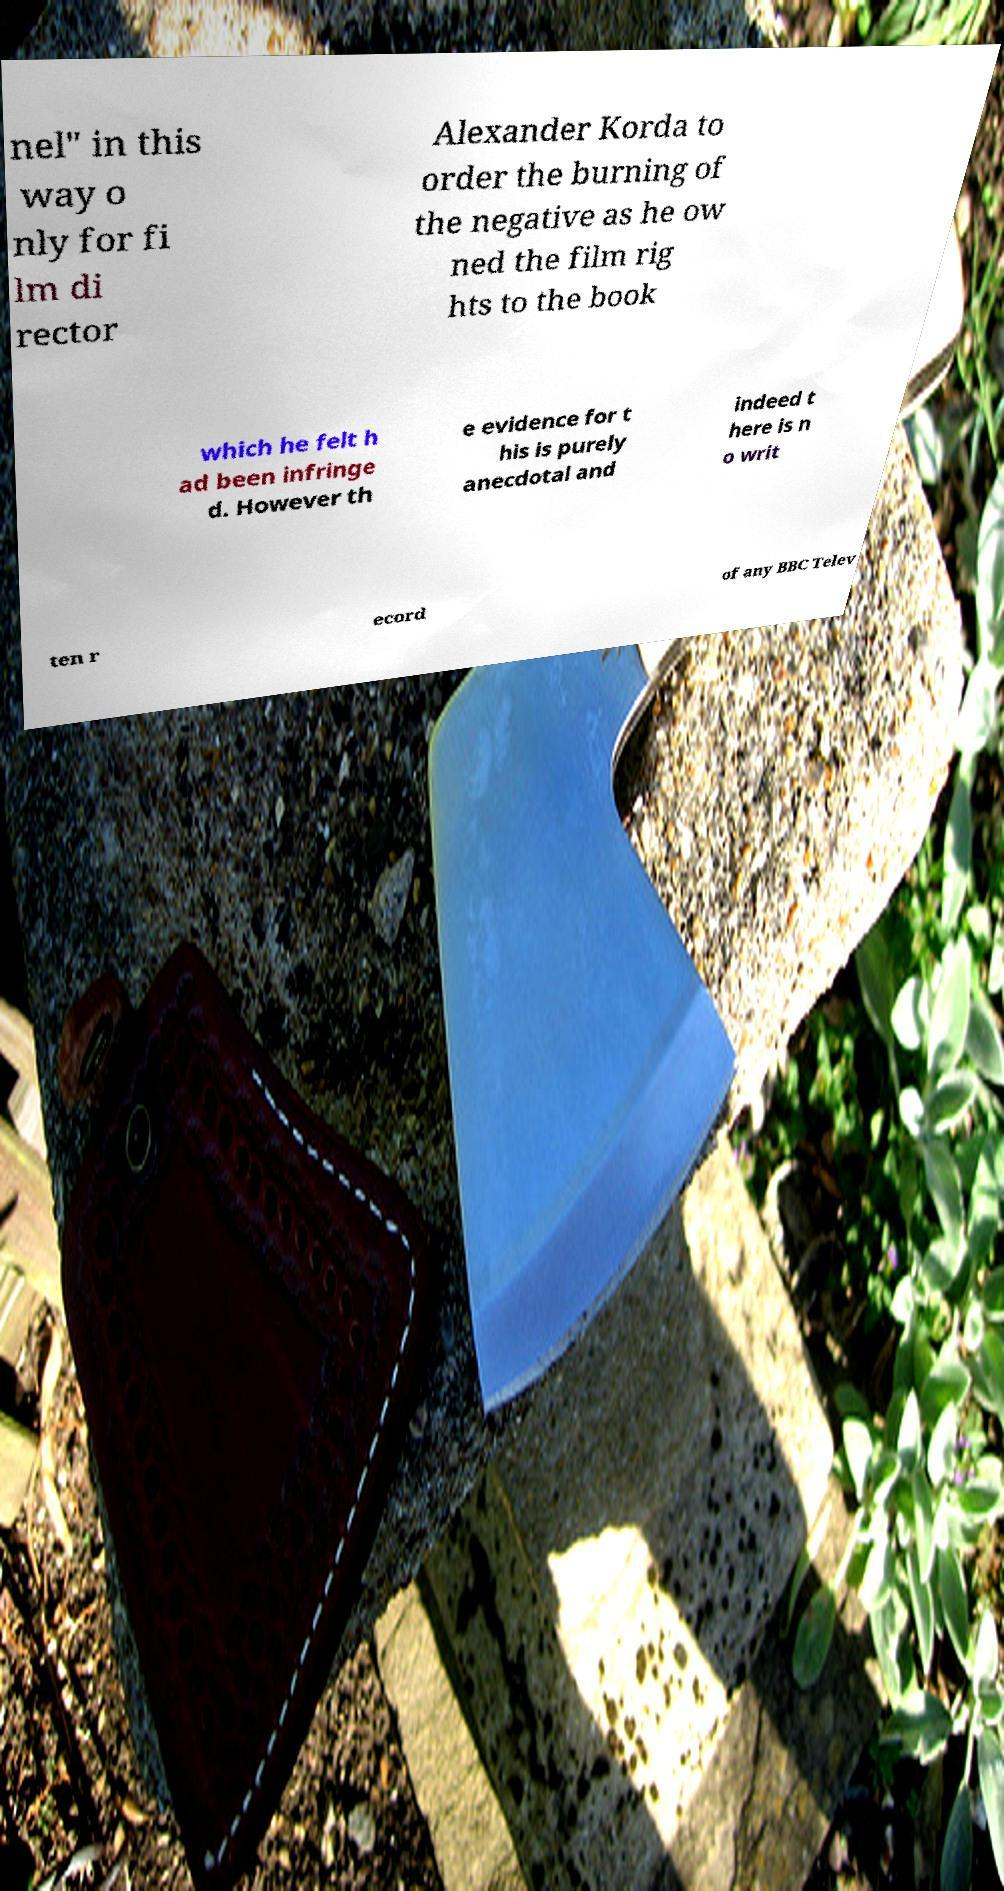What messages or text are displayed in this image? I need them in a readable, typed format. nel" in this way o nly for fi lm di rector Alexander Korda to order the burning of the negative as he ow ned the film rig hts to the book which he felt h ad been infringe d. However th e evidence for t his is purely anecdotal and indeed t here is n o writ ten r ecord of any BBC Telev 